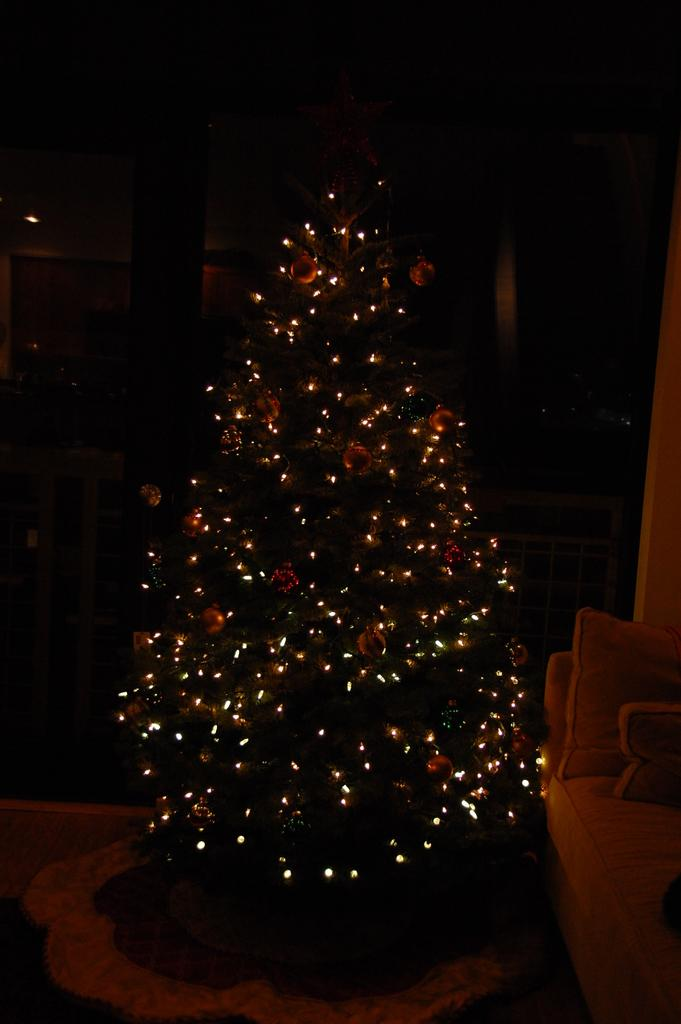What is the main object in the image? There is a Christmas tree in the image. What feature of the Christmas tree is mentioned in the facts? The Christmas tree has lights. What type of boundary can be seen surrounding the Christmas tree in the image? There is no boundary surrounding the Christmas tree in the image. How many people are seen kissing under the Christmas tree in the image? There are no people visible in the image, so it cannot be determined if anyone is kissing under the Christmas tree. 